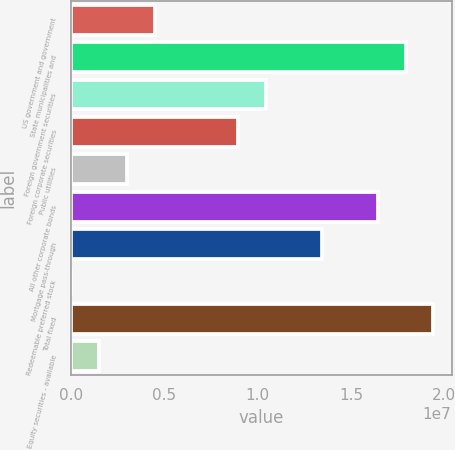Convert chart. <chart><loc_0><loc_0><loc_500><loc_500><bar_chart><fcel>US government and government<fcel>State municipalities and<fcel>Foreign government securities<fcel>Foreign corporate securities<fcel>Public utilities<fcel>All other corporate bonds<fcel>Mortgage pass-through<fcel>Redeemable preferred stock<fcel>Total fixed<fcel>Equity securities - available<nl><fcel>4.49245e+06<fcel>1.79201e+07<fcel>1.04603e+07<fcel>8.96833e+06<fcel>3.00049e+06<fcel>1.64281e+07<fcel>1.34442e+07<fcel>16573<fcel>1.94121e+07<fcel>1.50853e+06<nl></chart> 